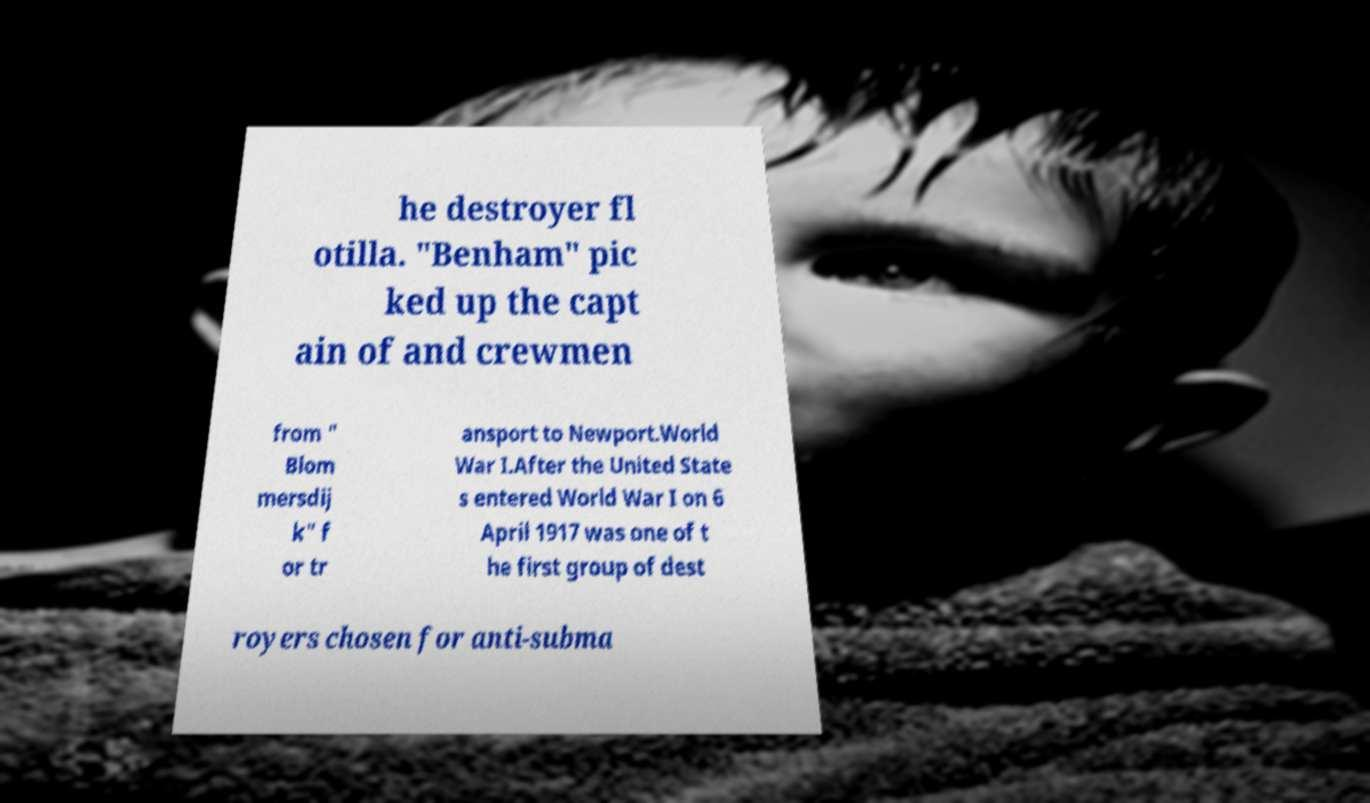Can you accurately transcribe the text from the provided image for me? he destroyer fl otilla. "Benham" pic ked up the capt ain of and crewmen from " Blom mersdij k" f or tr ansport to Newport.World War I.After the United State s entered World War I on 6 April 1917 was one of t he first group of dest royers chosen for anti-subma 